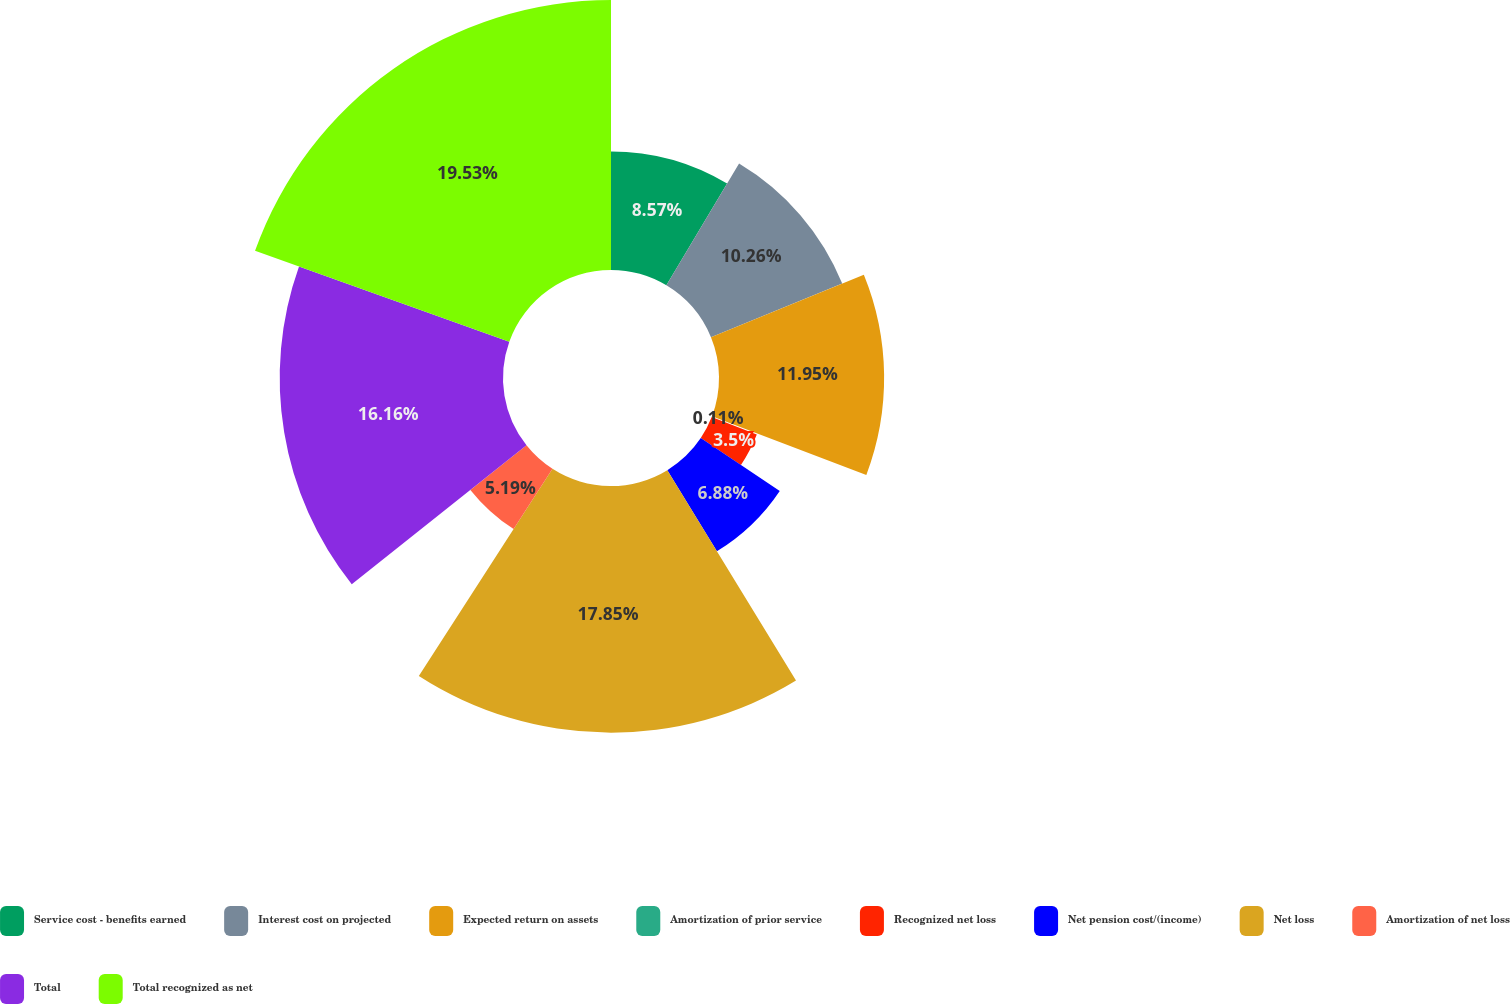Convert chart to OTSL. <chart><loc_0><loc_0><loc_500><loc_500><pie_chart><fcel>Service cost - benefits earned<fcel>Interest cost on projected<fcel>Expected return on assets<fcel>Amortization of prior service<fcel>Recognized net loss<fcel>Net pension cost/(income)<fcel>Net loss<fcel>Amortization of net loss<fcel>Total<fcel>Total recognized as net<nl><fcel>8.57%<fcel>10.26%<fcel>11.95%<fcel>0.11%<fcel>3.5%<fcel>6.88%<fcel>17.85%<fcel>5.19%<fcel>16.16%<fcel>19.54%<nl></chart> 